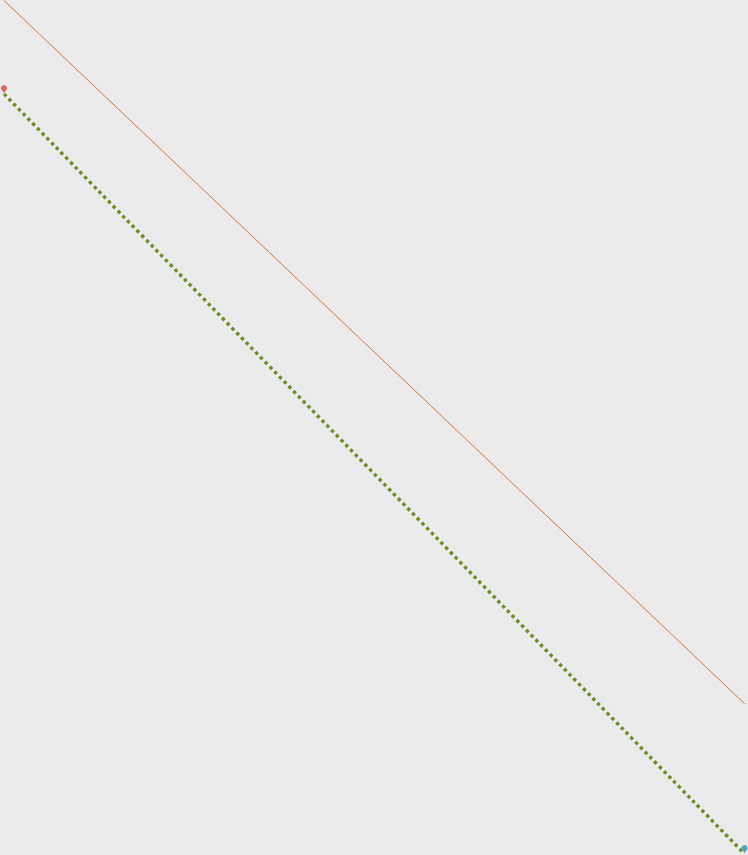<chart> <loc_0><loc_0><loc_500><loc_500><line_chart><ecel><fcel>2012<fcel>2013<nl><fcel>558.03<fcel>5452.99<fcel>4869.18<nl><fcel>4933.76<fcel>1058.68<fcel>119.2<nl><fcel>8121.36<fcel>570.42<fcel>2572.34<nl></chart> 